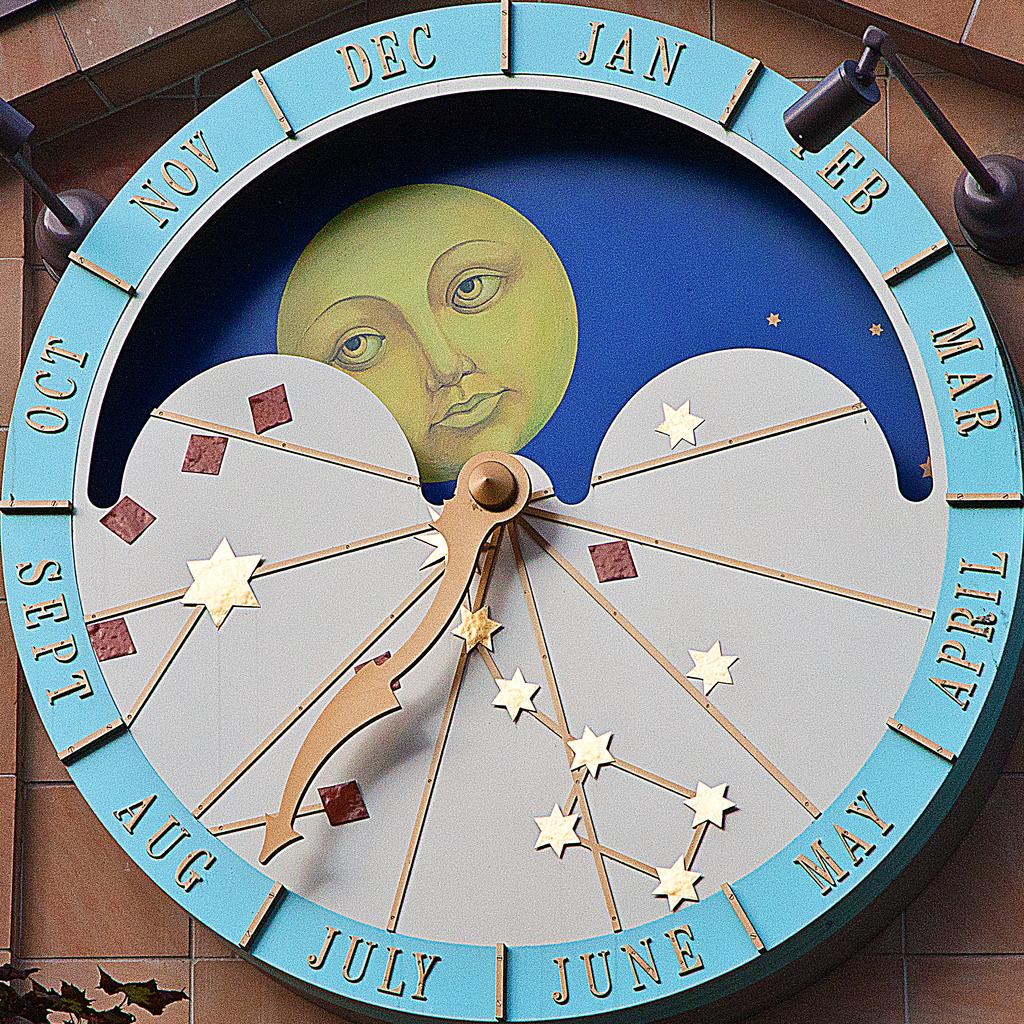<image>
Create a compact narrative representing the image presented. A large clock display depicting the different months is pointing to the month of August. 